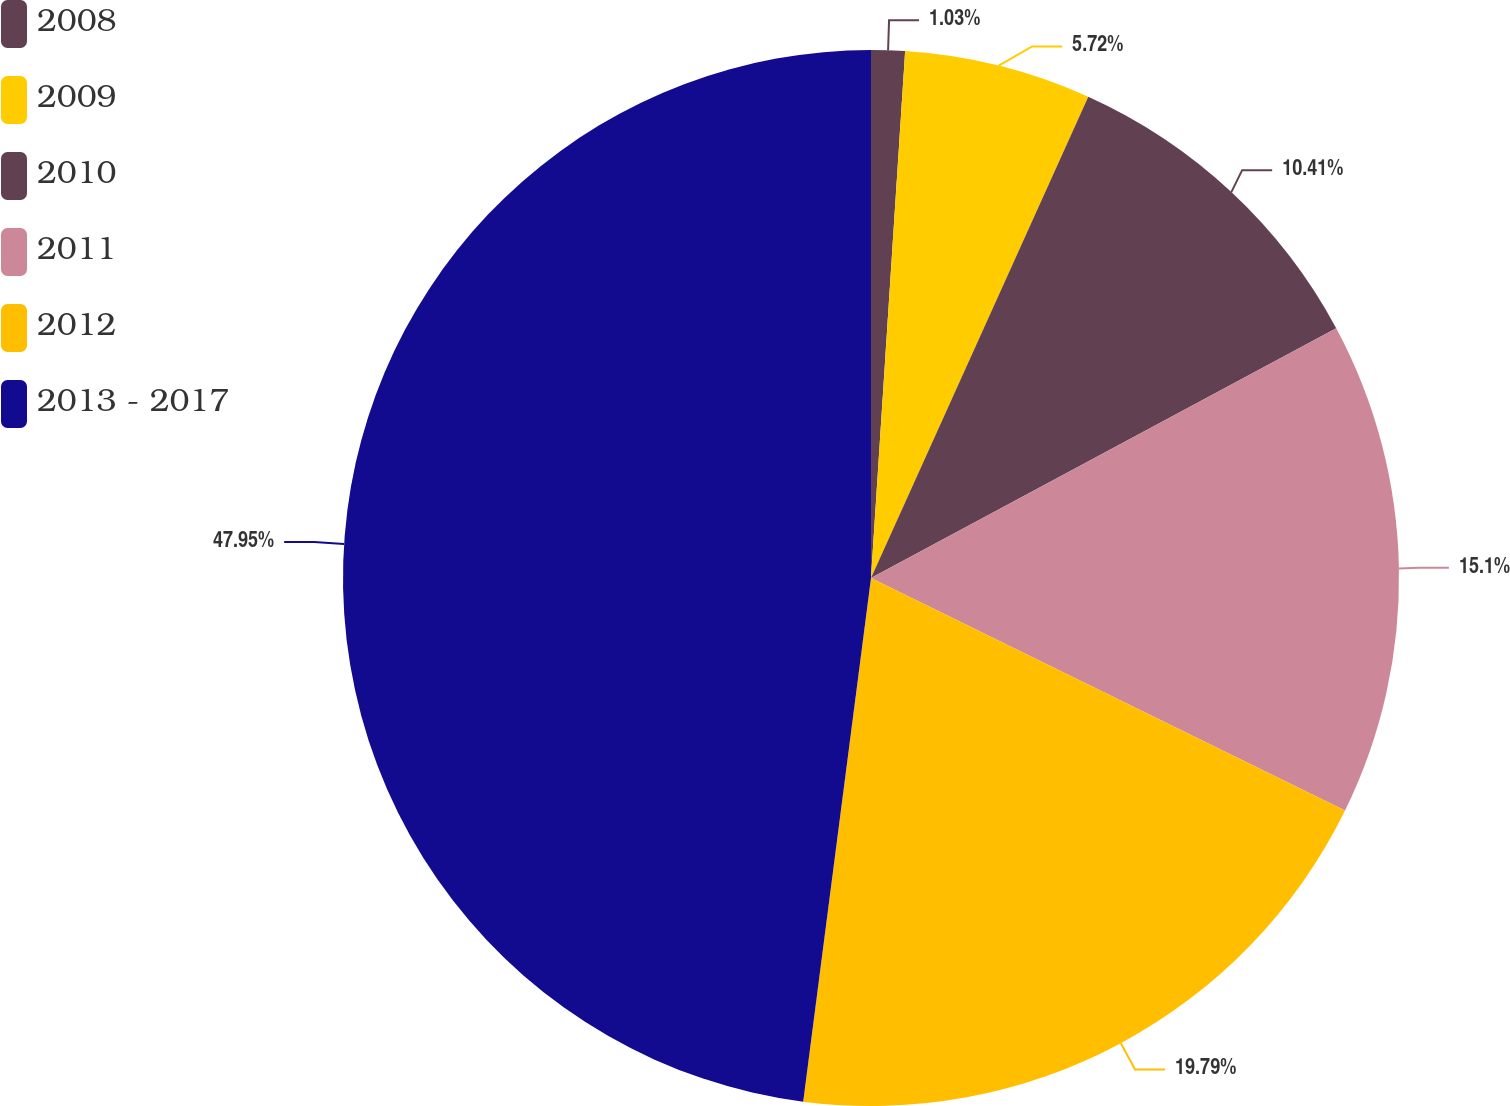<chart> <loc_0><loc_0><loc_500><loc_500><pie_chart><fcel>2008<fcel>2009<fcel>2010<fcel>2011<fcel>2012<fcel>2013 - 2017<nl><fcel>1.03%<fcel>5.72%<fcel>10.41%<fcel>15.1%<fcel>19.79%<fcel>47.95%<nl></chart> 